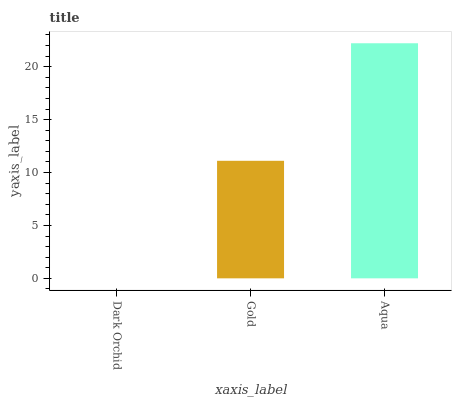Is Dark Orchid the minimum?
Answer yes or no. Yes. Is Aqua the maximum?
Answer yes or no. Yes. Is Gold the minimum?
Answer yes or no. No. Is Gold the maximum?
Answer yes or no. No. Is Gold greater than Dark Orchid?
Answer yes or no. Yes. Is Dark Orchid less than Gold?
Answer yes or no. Yes. Is Dark Orchid greater than Gold?
Answer yes or no. No. Is Gold less than Dark Orchid?
Answer yes or no. No. Is Gold the high median?
Answer yes or no. Yes. Is Gold the low median?
Answer yes or no. Yes. Is Aqua the high median?
Answer yes or no. No. Is Aqua the low median?
Answer yes or no. No. 